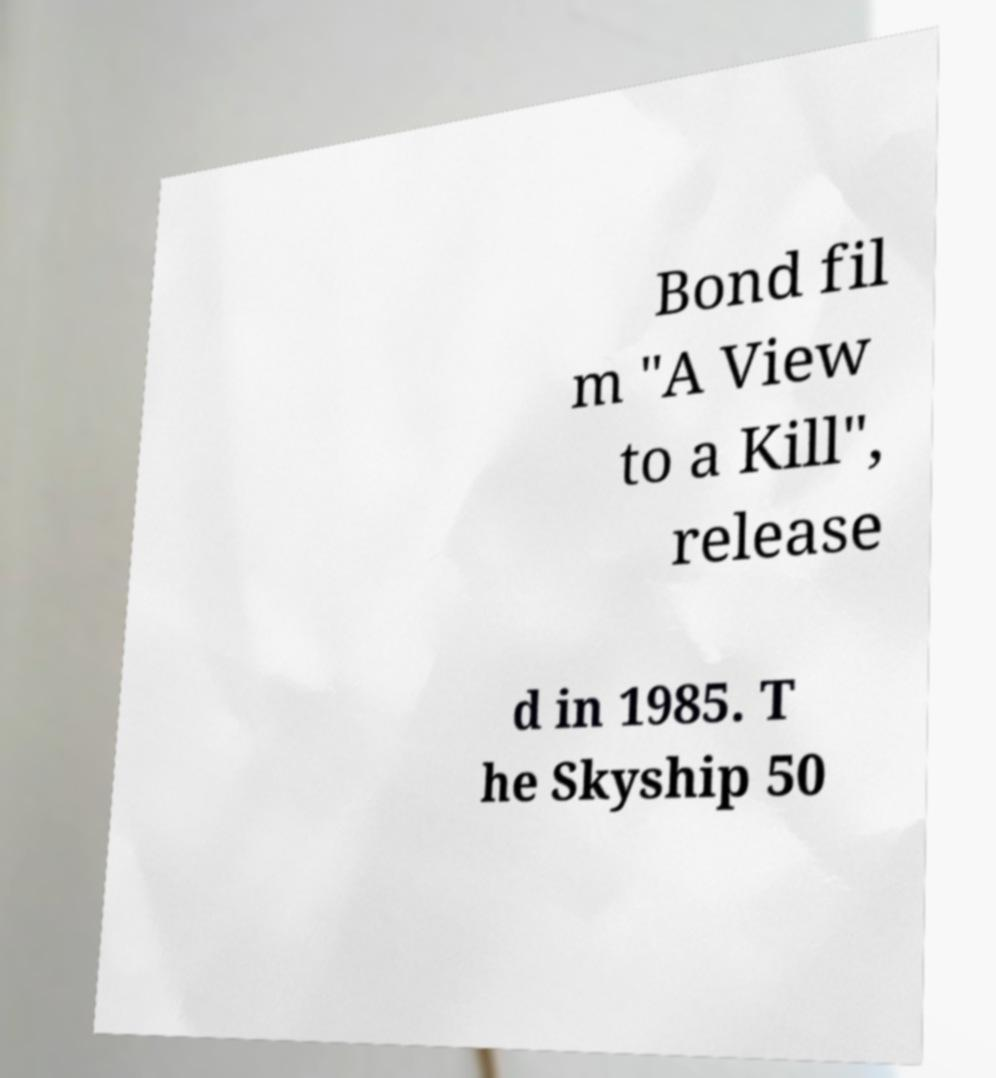There's text embedded in this image that I need extracted. Can you transcribe it verbatim? Bond fil m "A View to a Kill", release d in 1985. T he Skyship 50 